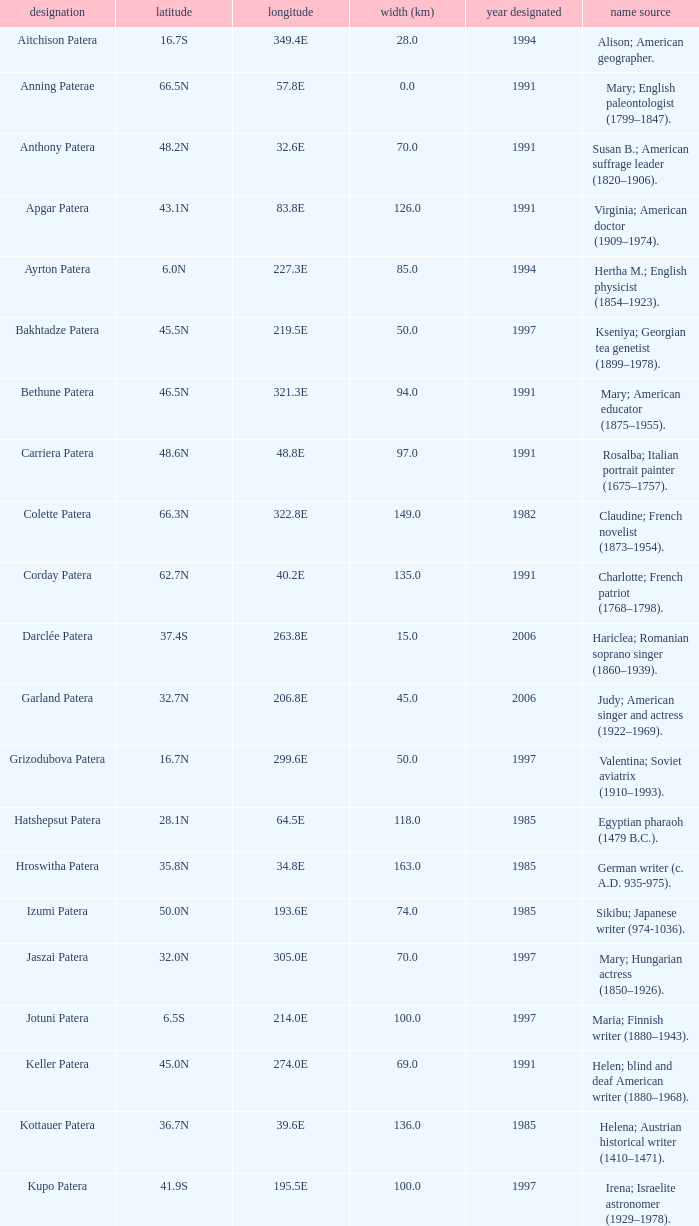What is the origin of the name of Keller Patera?  Helen; blind and deaf American writer (1880–1968). 